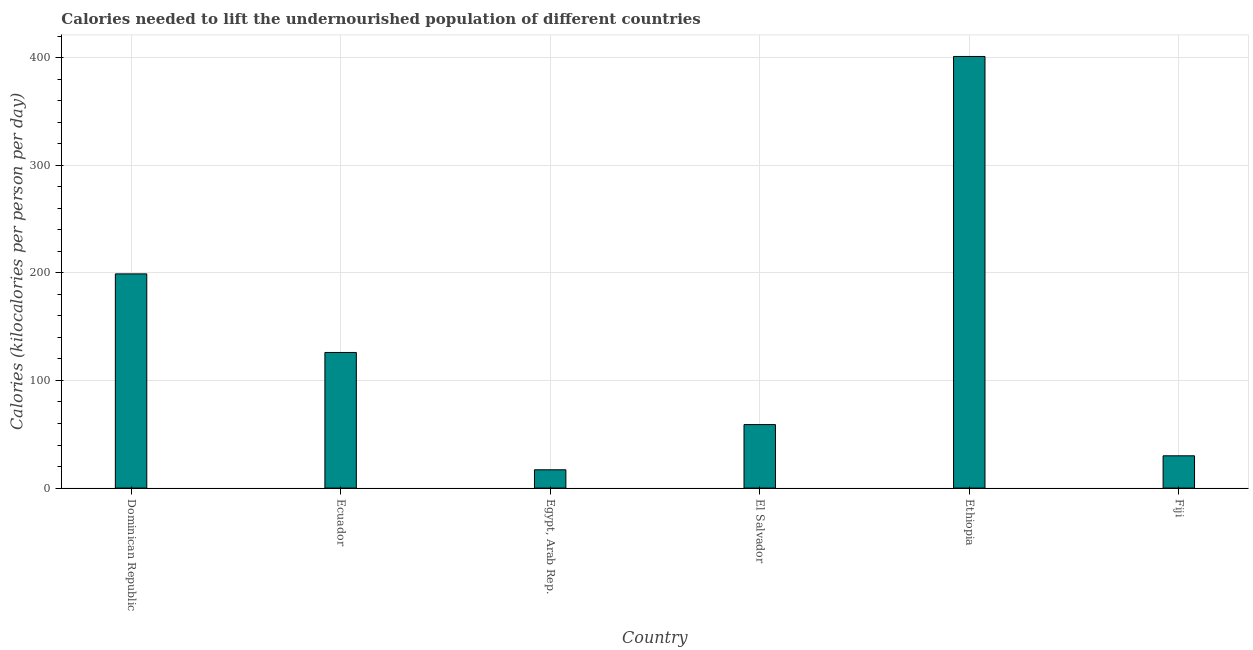Does the graph contain any zero values?
Give a very brief answer. No. Does the graph contain grids?
Offer a very short reply. Yes. What is the title of the graph?
Ensure brevity in your answer.  Calories needed to lift the undernourished population of different countries. What is the label or title of the X-axis?
Offer a very short reply. Country. What is the label or title of the Y-axis?
Your answer should be compact. Calories (kilocalories per person per day). Across all countries, what is the maximum depth of food deficit?
Give a very brief answer. 401. In which country was the depth of food deficit maximum?
Give a very brief answer. Ethiopia. In which country was the depth of food deficit minimum?
Ensure brevity in your answer.  Egypt, Arab Rep. What is the sum of the depth of food deficit?
Your response must be concise. 832. What is the difference between the depth of food deficit in El Salvador and Ethiopia?
Your answer should be compact. -342. What is the average depth of food deficit per country?
Make the answer very short. 138.67. What is the median depth of food deficit?
Your answer should be compact. 92.5. In how many countries, is the depth of food deficit greater than 140 kilocalories?
Make the answer very short. 2. What is the ratio of the depth of food deficit in Dominican Republic to that in Ethiopia?
Offer a terse response. 0.5. What is the difference between the highest and the second highest depth of food deficit?
Your response must be concise. 202. What is the difference between the highest and the lowest depth of food deficit?
Give a very brief answer. 384. In how many countries, is the depth of food deficit greater than the average depth of food deficit taken over all countries?
Ensure brevity in your answer.  2. Are all the bars in the graph horizontal?
Provide a succinct answer. No. How many countries are there in the graph?
Keep it short and to the point. 6. Are the values on the major ticks of Y-axis written in scientific E-notation?
Give a very brief answer. No. What is the Calories (kilocalories per person per day) in Dominican Republic?
Keep it short and to the point. 199. What is the Calories (kilocalories per person per day) in Ecuador?
Your answer should be compact. 126. What is the Calories (kilocalories per person per day) in Egypt, Arab Rep.?
Make the answer very short. 17. What is the Calories (kilocalories per person per day) in Ethiopia?
Give a very brief answer. 401. What is the difference between the Calories (kilocalories per person per day) in Dominican Republic and Ecuador?
Provide a succinct answer. 73. What is the difference between the Calories (kilocalories per person per day) in Dominican Republic and Egypt, Arab Rep.?
Your response must be concise. 182. What is the difference between the Calories (kilocalories per person per day) in Dominican Republic and El Salvador?
Offer a terse response. 140. What is the difference between the Calories (kilocalories per person per day) in Dominican Republic and Ethiopia?
Offer a very short reply. -202. What is the difference between the Calories (kilocalories per person per day) in Dominican Republic and Fiji?
Your response must be concise. 169. What is the difference between the Calories (kilocalories per person per day) in Ecuador and Egypt, Arab Rep.?
Provide a short and direct response. 109. What is the difference between the Calories (kilocalories per person per day) in Ecuador and El Salvador?
Keep it short and to the point. 67. What is the difference between the Calories (kilocalories per person per day) in Ecuador and Ethiopia?
Your answer should be compact. -275. What is the difference between the Calories (kilocalories per person per day) in Ecuador and Fiji?
Make the answer very short. 96. What is the difference between the Calories (kilocalories per person per day) in Egypt, Arab Rep. and El Salvador?
Offer a very short reply. -42. What is the difference between the Calories (kilocalories per person per day) in Egypt, Arab Rep. and Ethiopia?
Your answer should be compact. -384. What is the difference between the Calories (kilocalories per person per day) in El Salvador and Ethiopia?
Make the answer very short. -342. What is the difference between the Calories (kilocalories per person per day) in El Salvador and Fiji?
Offer a very short reply. 29. What is the difference between the Calories (kilocalories per person per day) in Ethiopia and Fiji?
Offer a very short reply. 371. What is the ratio of the Calories (kilocalories per person per day) in Dominican Republic to that in Ecuador?
Offer a very short reply. 1.58. What is the ratio of the Calories (kilocalories per person per day) in Dominican Republic to that in Egypt, Arab Rep.?
Ensure brevity in your answer.  11.71. What is the ratio of the Calories (kilocalories per person per day) in Dominican Republic to that in El Salvador?
Your response must be concise. 3.37. What is the ratio of the Calories (kilocalories per person per day) in Dominican Republic to that in Ethiopia?
Provide a short and direct response. 0.5. What is the ratio of the Calories (kilocalories per person per day) in Dominican Republic to that in Fiji?
Your answer should be very brief. 6.63. What is the ratio of the Calories (kilocalories per person per day) in Ecuador to that in Egypt, Arab Rep.?
Ensure brevity in your answer.  7.41. What is the ratio of the Calories (kilocalories per person per day) in Ecuador to that in El Salvador?
Keep it short and to the point. 2.14. What is the ratio of the Calories (kilocalories per person per day) in Ecuador to that in Ethiopia?
Your answer should be compact. 0.31. What is the ratio of the Calories (kilocalories per person per day) in Egypt, Arab Rep. to that in El Salvador?
Your answer should be compact. 0.29. What is the ratio of the Calories (kilocalories per person per day) in Egypt, Arab Rep. to that in Ethiopia?
Provide a succinct answer. 0.04. What is the ratio of the Calories (kilocalories per person per day) in Egypt, Arab Rep. to that in Fiji?
Your answer should be very brief. 0.57. What is the ratio of the Calories (kilocalories per person per day) in El Salvador to that in Ethiopia?
Offer a terse response. 0.15. What is the ratio of the Calories (kilocalories per person per day) in El Salvador to that in Fiji?
Your answer should be very brief. 1.97. What is the ratio of the Calories (kilocalories per person per day) in Ethiopia to that in Fiji?
Provide a short and direct response. 13.37. 